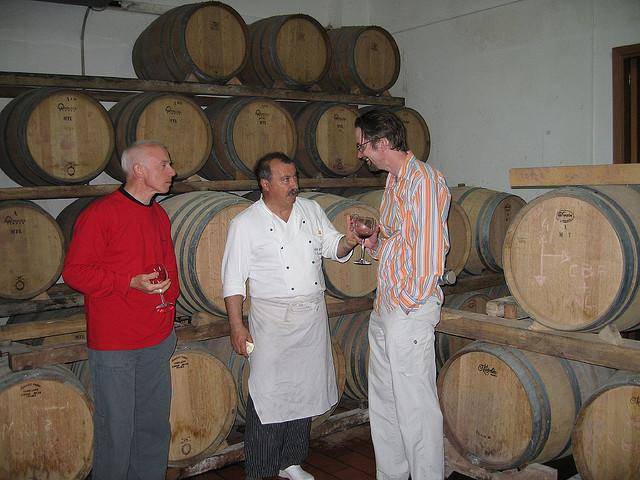What is contained inside the brown barrels? Please explain your reasoning. wine. This drink is often kept in brown barrels on racks in an indoor environment, and two of the people in the room are drinking a grape-color liquid out of long stemmed drinking glasses. 